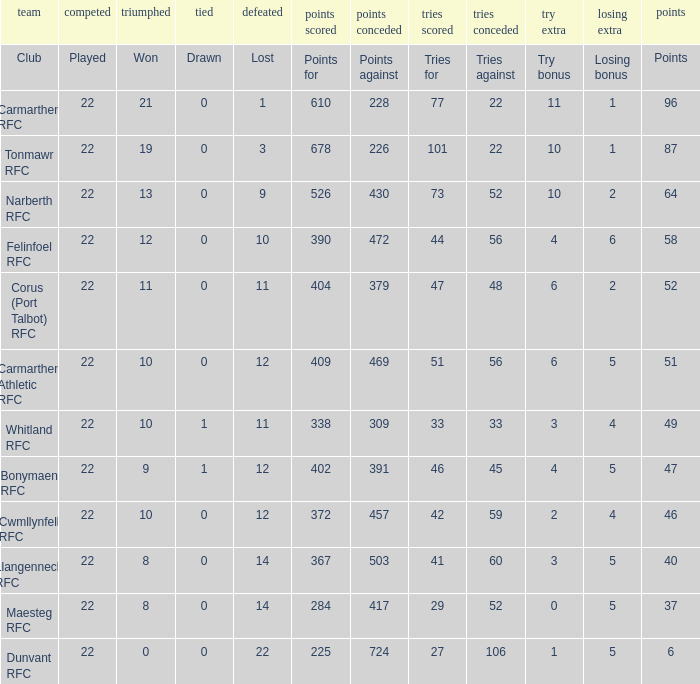Name the losing bonus for 27 5.0. 